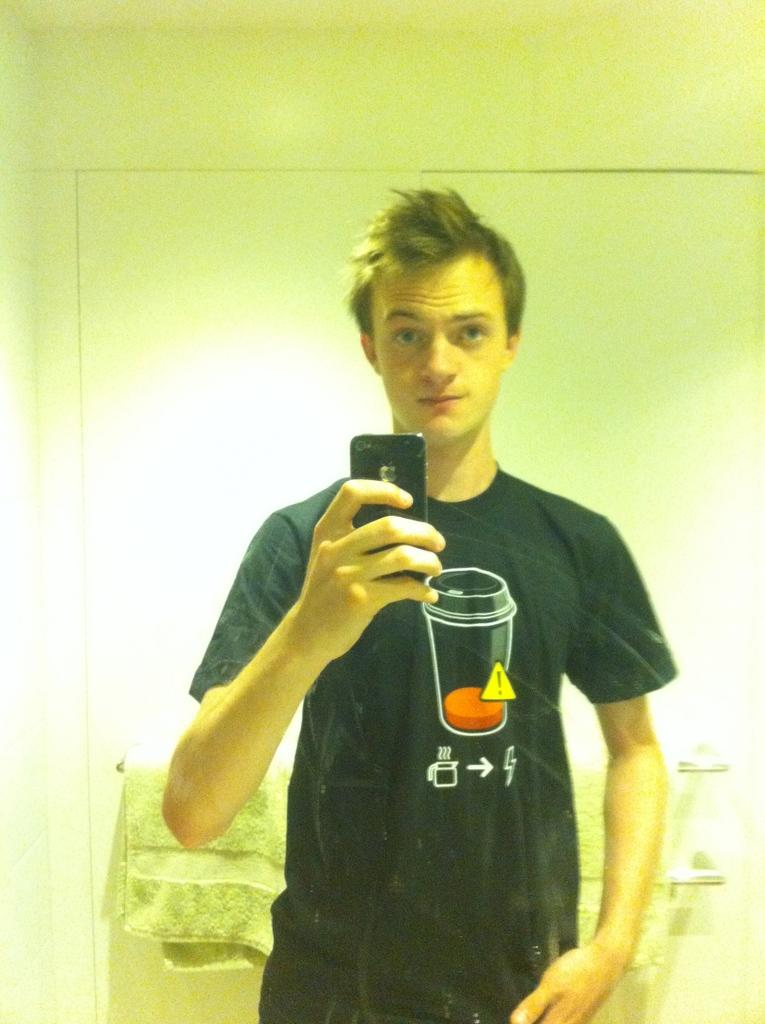Who or what is the main subject in the image? There is a person in the image. What is behind the person in the image? The person is in front of a wall. What is the person wearing in the image? The person is wearing clothes. What object is the person holding in the image? The person is holding a phone in his hand. Where is the towel located in the image? There is a towel in the bottom left of the image. What is the size of the square in the image? There is no square present in the image. What team does the person in the image belong to? The image does not provide any information about the person's team affiliation. 